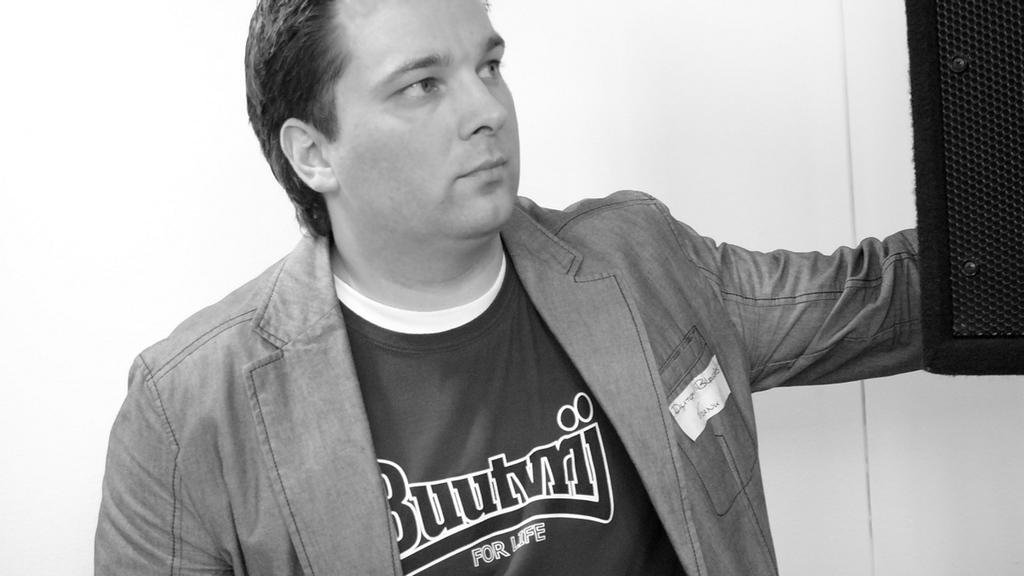<image>
Write a terse but informative summary of the picture. A guy wearing a shirt that says Buutvrij For Life. 